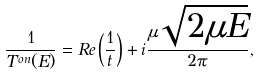<formula> <loc_0><loc_0><loc_500><loc_500>\frac { 1 } { T ^ { o n } ( E ) } = R e \left ( \frac { 1 } { t } \right ) + i \frac { \mu \sqrt { 2 \mu E } } { 2 \pi } ,</formula> 